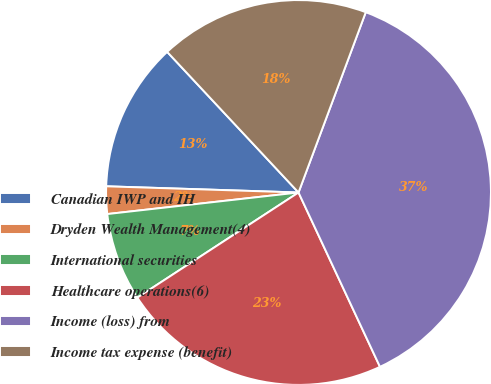Convert chart. <chart><loc_0><loc_0><loc_500><loc_500><pie_chart><fcel>Canadian IWP and IH<fcel>Dryden Wealth Management(4)<fcel>International securities<fcel>Healthcare operations(6)<fcel>Income (loss) from<fcel>Income tax expense (benefit)<nl><fcel>12.53%<fcel>2.3%<fcel>7.41%<fcel>22.76%<fcel>37.36%<fcel>17.64%<nl></chart> 